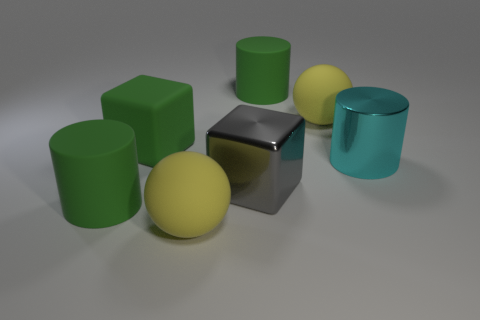What number of things are either yellow matte things that are in front of the cyan cylinder or cyan balls?
Keep it short and to the point. 1. Are any small blue blocks visible?
Your response must be concise. No. There is a large cube that is to the right of the green rubber cube; what material is it?
Offer a very short reply. Metal. What number of tiny things are either cyan cylinders or gray metallic balls?
Ensure brevity in your answer.  0. What is the color of the rubber block?
Offer a terse response. Green. There is a green rubber cylinder behind the large gray block; are there any large balls that are in front of it?
Provide a succinct answer. Yes. Is the number of big things to the left of the green cube less than the number of yellow objects?
Your answer should be compact. Yes. Is the big green object in front of the big metallic cylinder made of the same material as the big green cube?
Your response must be concise. Yes. What color is the object that is the same material as the big cyan cylinder?
Your answer should be very brief. Gray. Are there fewer green objects that are to the left of the gray metal thing than big matte things right of the large green block?
Your answer should be very brief. Yes. 